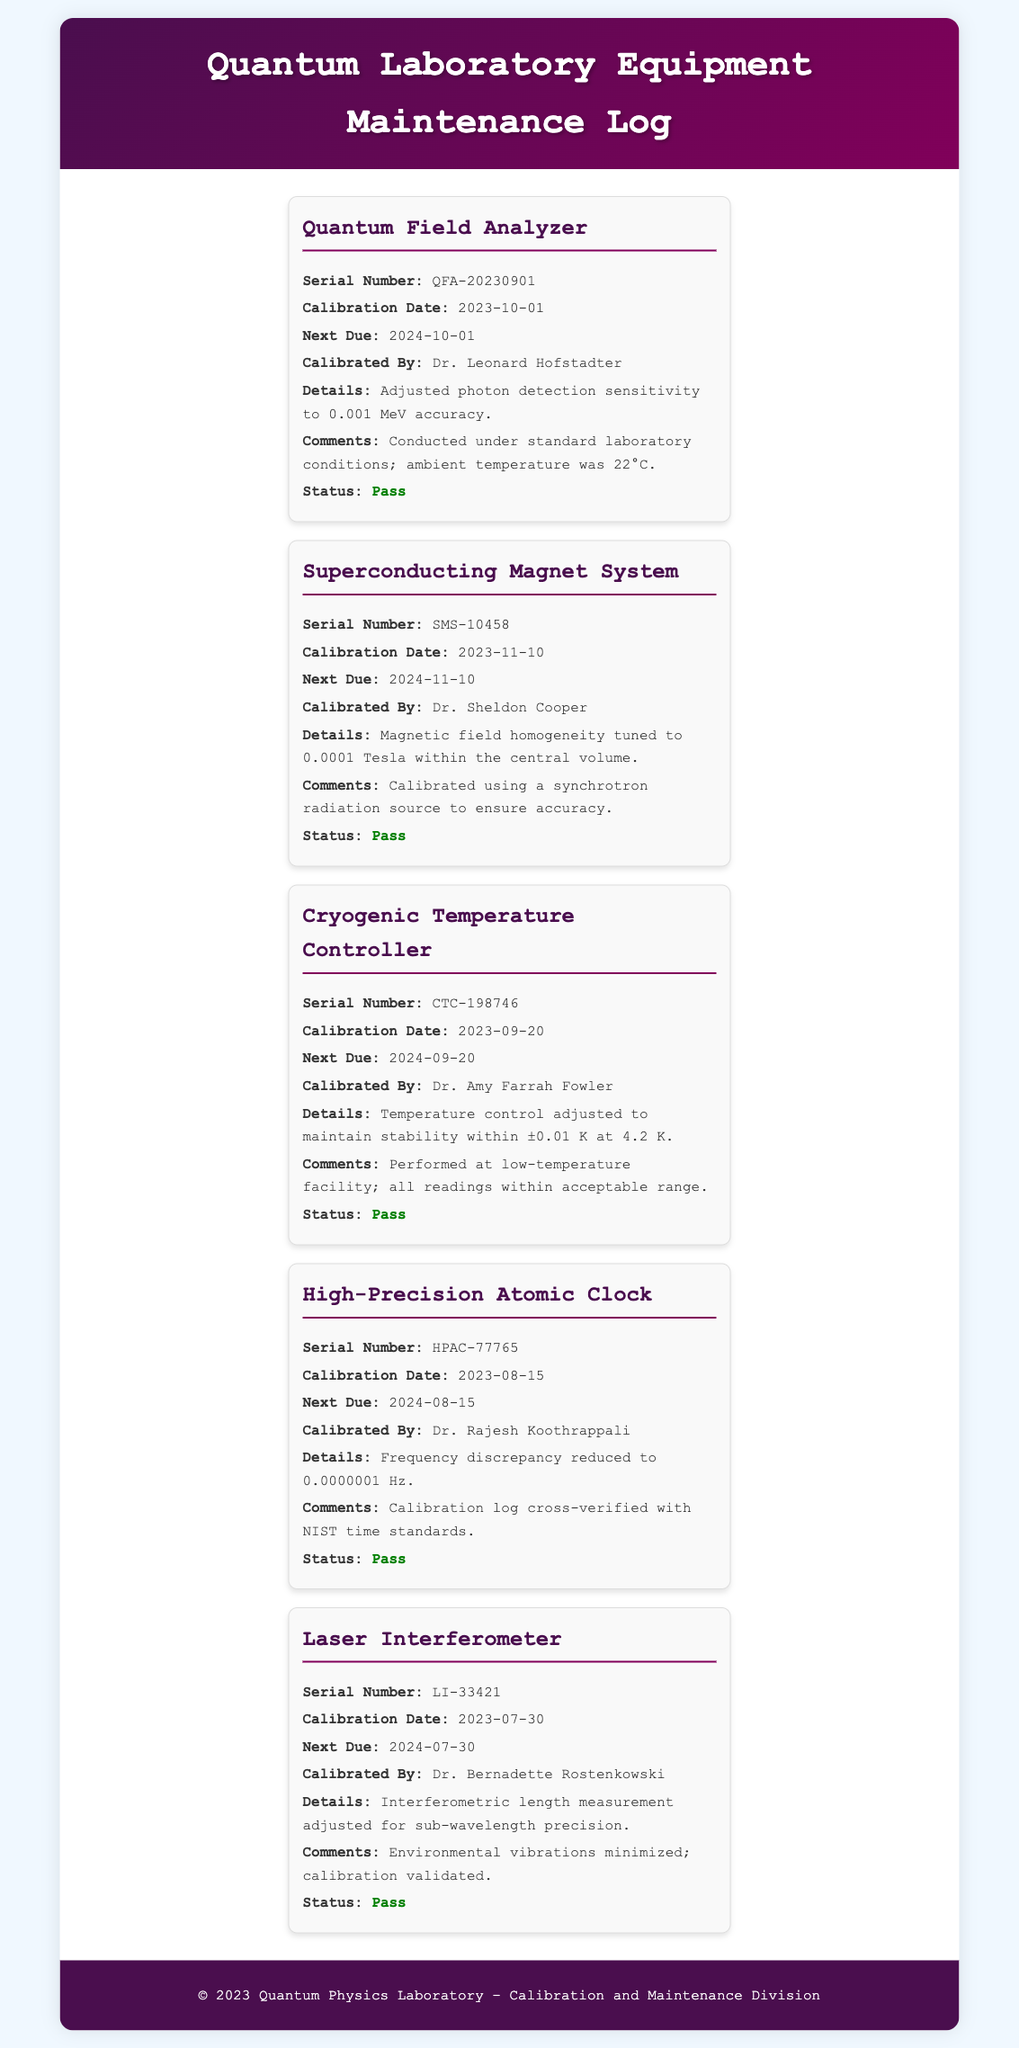What is the serial number of the Quantum Field Analyzer? The serial number is a unique identifier for the equipment listed in the document.
Answer: QFA-20230901 Who calibrated the Superconducting Magnet System? This information indicates who performed the calibration, which can be critical for accountability.
Answer: Dr. Sheldon Cooper When is the next due calibration for the Cryogenic Temperature Controller? The next due date is important for scheduling future calibrations to ensure equipment reliability.
Answer: 2024-09-20 What detail was adjusted for the High-Precision Atomic Clock? This reflects the specific parameters that were modified during calibration to improve performance.
Answer: Frequency discrepancy reduced to 0.0000001 Hz How many calibration records are listed in the document? The total number of records can provide insight into the laboratory's calibration activities.
Answer: 5 What is the status of the Laser Interferometer? Understanding the status of equipment is crucial for assessing its readiness for use.
Answer: Pass Which equipment had its calibration conducted under standard laboratory conditions? This information highlights which equipment was calibrated in a controlled environment, potentially indicating reliability.
Answer: Quantum Field Analyzer What was the main focus of the calibration for the Cryogenic Temperature Controller? The focus reveals what specific aspect of the equipment's functionality was targeted during calibration efforts.
Answer: Maintain stability within ±0.01 K at 4.2 K 